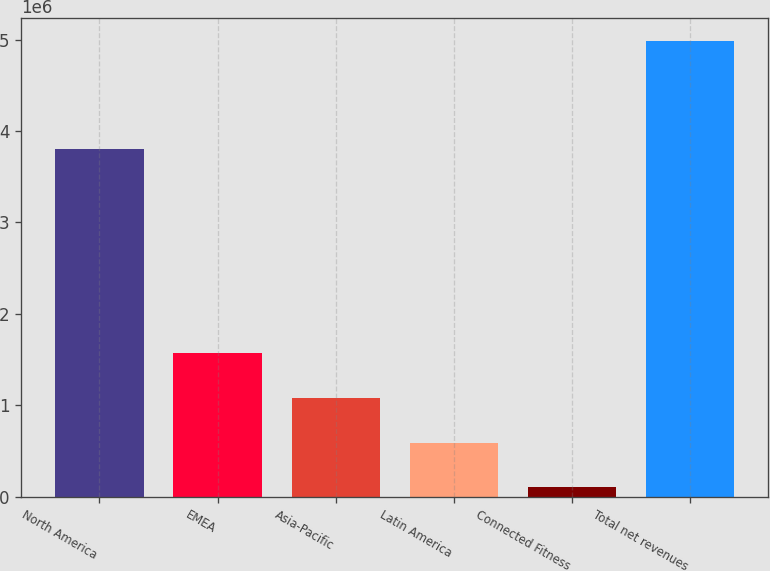Convert chart to OTSL. <chart><loc_0><loc_0><loc_500><loc_500><bar_chart><fcel>North America<fcel>EMEA<fcel>Asia-Pacific<fcel>Latin America<fcel>Connected Fitness<fcel>Total net revenues<nl><fcel>3.80241e+06<fcel>1.56808e+06<fcel>1.07934e+06<fcel>590607<fcel>101870<fcel>4.98924e+06<nl></chart> 